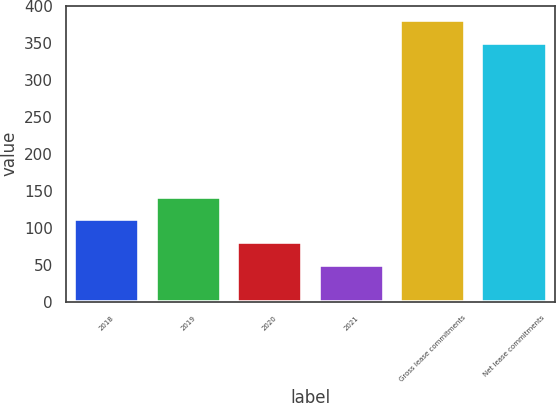<chart> <loc_0><loc_0><loc_500><loc_500><bar_chart><fcel>2018<fcel>2019<fcel>2020<fcel>2021<fcel>Gross lease commitments<fcel>Net lease commitments<nl><fcel>111.34<fcel>142.11<fcel>80.57<fcel>49.8<fcel>381.57<fcel>350.8<nl></chart> 